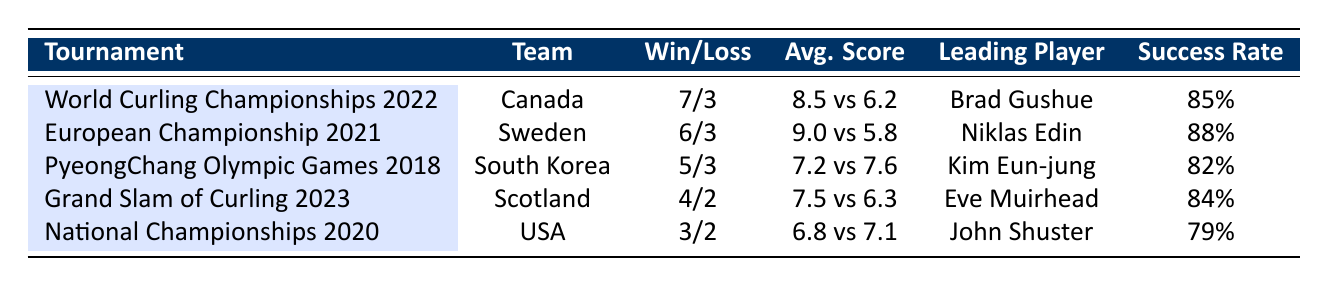What is the win-loss record for Canada in the World Curling Championships 2022? The table shows that Canada played 10 matches, with 7 wins and 3 losses during the World Curling Championships in 2022. This is explicitly stated in the table under the corresponding tournament and team columns.
Answer: 7 wins, 3 losses Which team had the highest average score in their tournament? When comparing the average scores from the table, Canada had an average score of 8.5, Sweden had 9.0, South Korea had 7.2, Scotland had 7.5, and the USA had 6.8. Sweden's average score of 9.0 is the highest.
Answer: Sweden Did any team win more matches than they lost in their tournament? Looking at the wins and losses in the table, Canada, Sweden, South Korea, and Scotland all have winning records (more wins than losses), confirming that they won more matches than they lost.
Answer: Yes What is the difference between the average scores of the USA and Scotland? The average score for the USA was 6.8, and for Scotland, it was 7.5. To find the difference, we subtract USA's average score from Scotland's: 7.5 - 6.8 = 0.7.
Answer: 0.7 Which leading player had the highest success rate among the listed players? The success rates for the leading players are as follows: Brad Gushue (85%), Niklas Edin (88%), Kim Eun-jung (82%), Eve Muirhead (84%), and John Shuster (79%). The highest success rate is attributed to Niklas Edin at 88%.
Answer: Niklas Edin What was the average opponent score of the team that won the Grand Slam of Curling 2023? The table indicates that Scotland won the Grand Slam of Curling 2023 and had an average opponent score of 6.3. This can be found directly in the rows for Scotland under that tournament.
Answer: 6.3 Is the number of matches played by South Korea greater than that of the USA? South Korea played 8 matches according to the table, while the USA played 5 matches. Since 8 is greater than 5, the statement is true.
Answer: Yes What was the average score of the team with the leading player "Eve Muirhead"? According to the table, Eve Muirhead is the leading player for Scotland, who had an average score of 7.5. This information is contained in the row for Scotland.
Answer: 7.5 